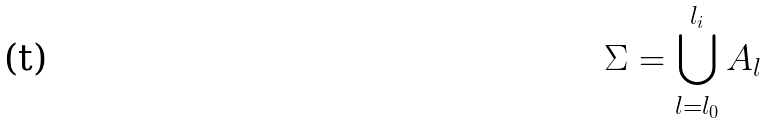Convert formula to latex. <formula><loc_0><loc_0><loc_500><loc_500>\Sigma = \bigcup _ { l = l _ { 0 } } ^ { l _ { i } } A _ { l }</formula> 